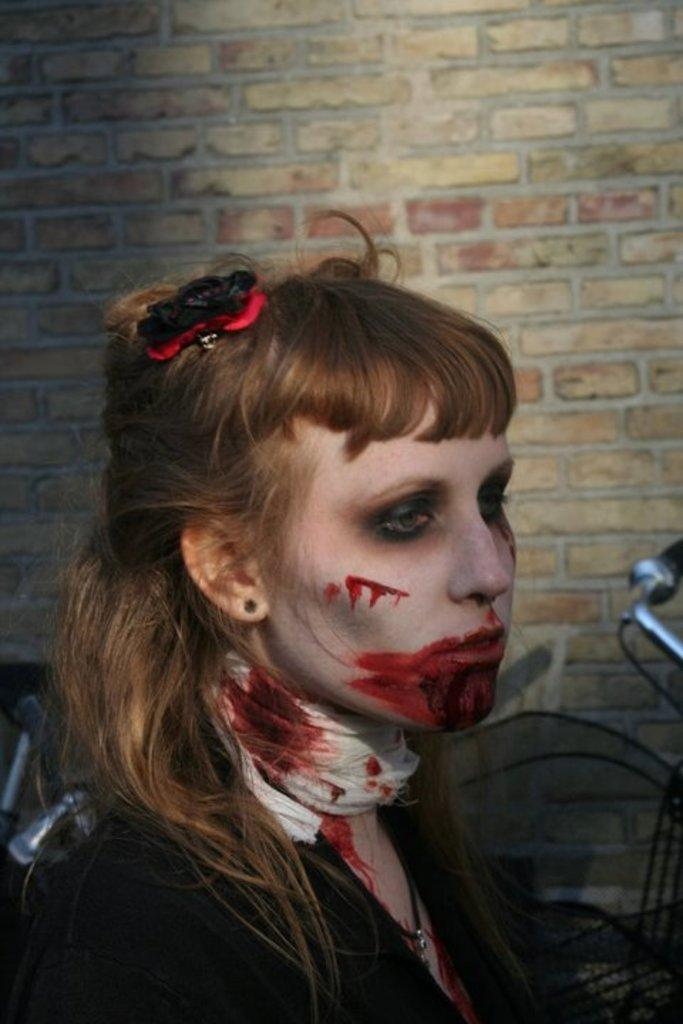Who is present in the image? There is a lady in the image. What can be seen in the background of the image? There is a wall in the background of the image. What object is also visible in the image? There is a cycle in the image. What type of stew is the lady cooking in the image? There is no indication in the image that the lady is cooking or preparing any type of stew. 